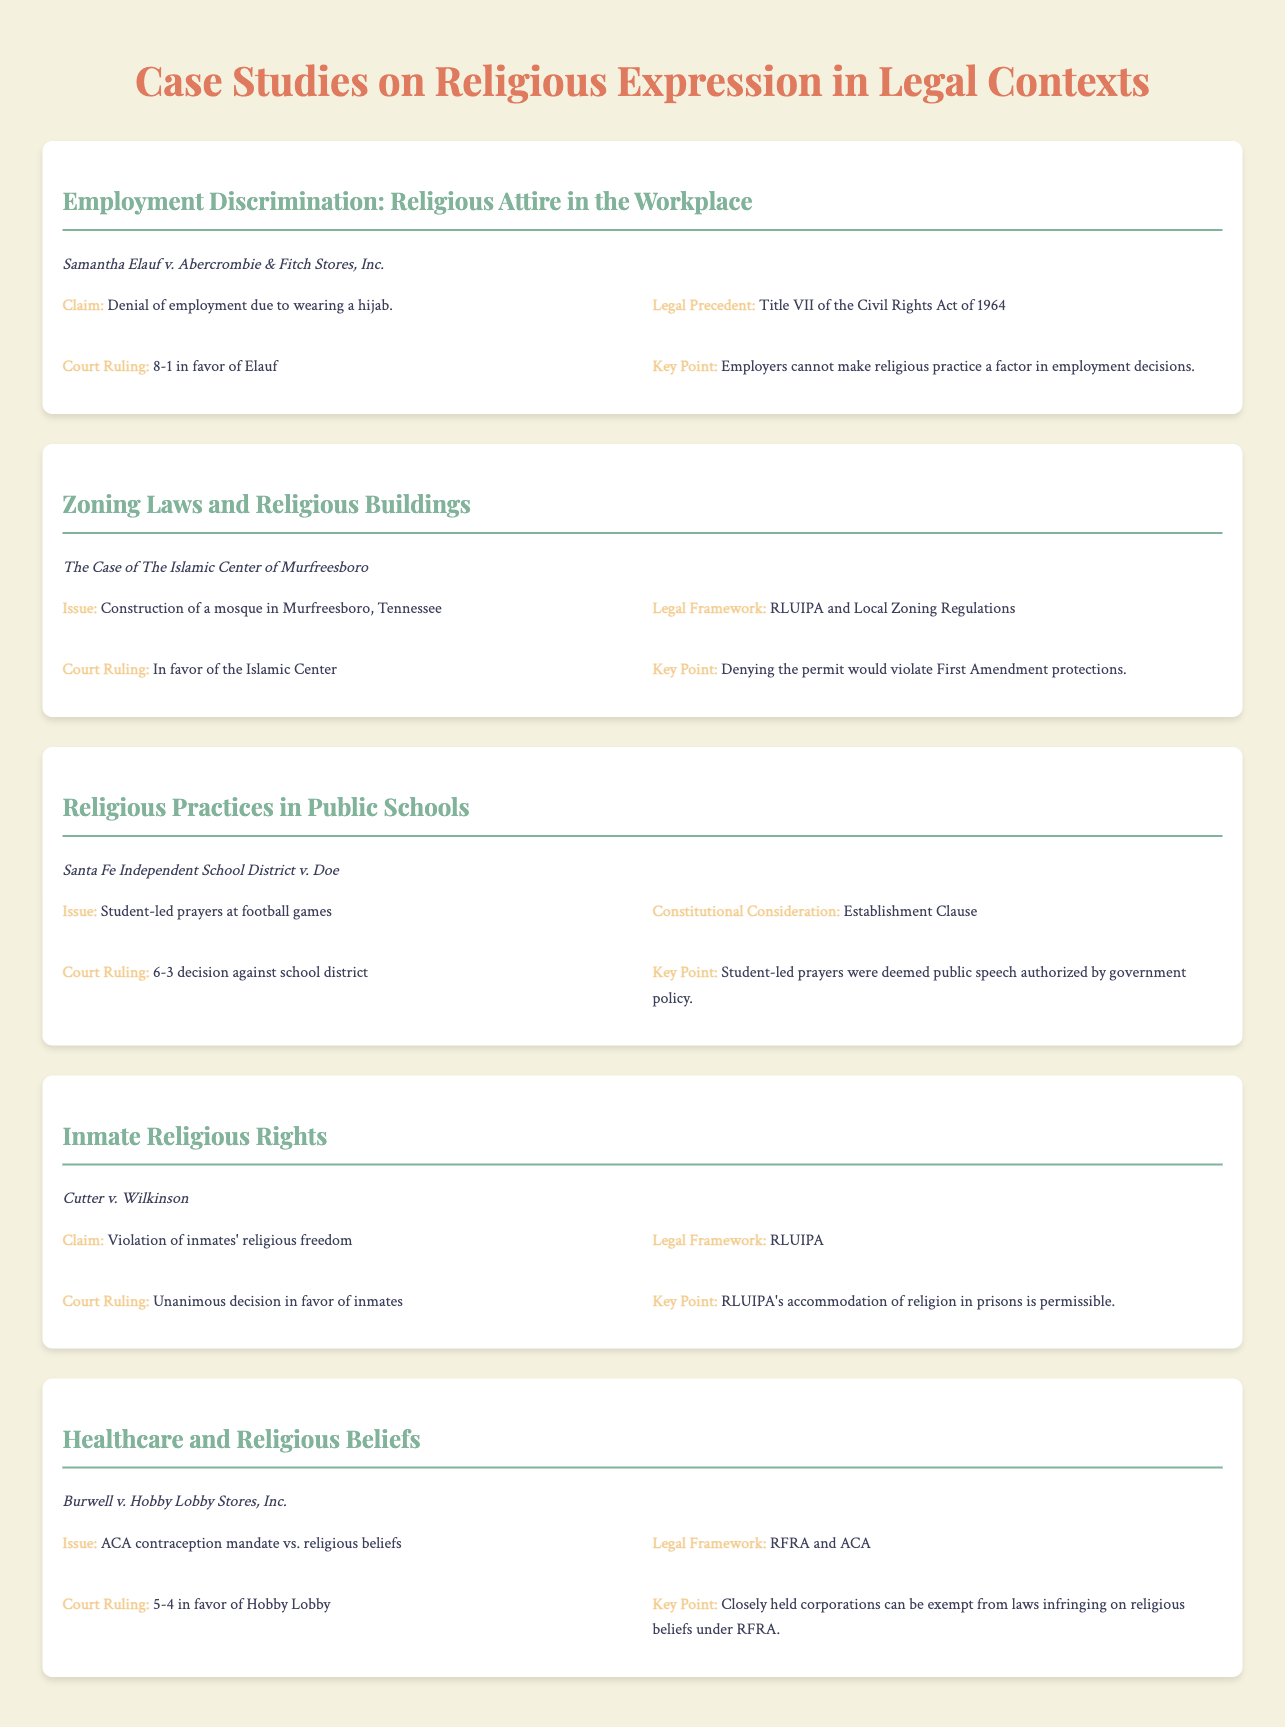What was the claim in Samantha Elauf's case? The claim was the denial of employment due to wearing a hijab.
Answer: Denial of employment due to wearing a hijab What was the court ruling in the case regarding the Islamic Center of Murfreesboro? The court ruled in favor of the Islamic Center.
Answer: In favor of the Islamic Center Which Constitutional consideration was highlighted in the Santa Fe Independent School District case? The consideration was the Establishment Clause.
Answer: Establishment Clause What legal framework was involved in the Cutter v. Wilkinson case? The legal framework was RLUIPA.
Answer: RLUIPA What was the issue in Burwell v. Hobby Lobby Stores, Inc.? The issue was the ACA contraception mandate vs. religious beliefs.
Answer: ACA contraception mandate vs. religious beliefs What was the key point regarding employer responsibilities in Elauf's case? Employers cannot make religious practice a factor in employment decisions.
Answer: Employers cannot make religious practice a factor in employment decisions What was the ruling majority in the case of Burwell v. Hobby Lobby? The ruling was 5-4 in favor of Hobby Lobby.
Answer: 5-4 in favor of Hobby Lobby What did the court decide regarding inmate religious rights in Cutter v. Wilkinson? The decision was unanimous in favor of inmates.
Answer: Unanimous decision in favor of inmates 